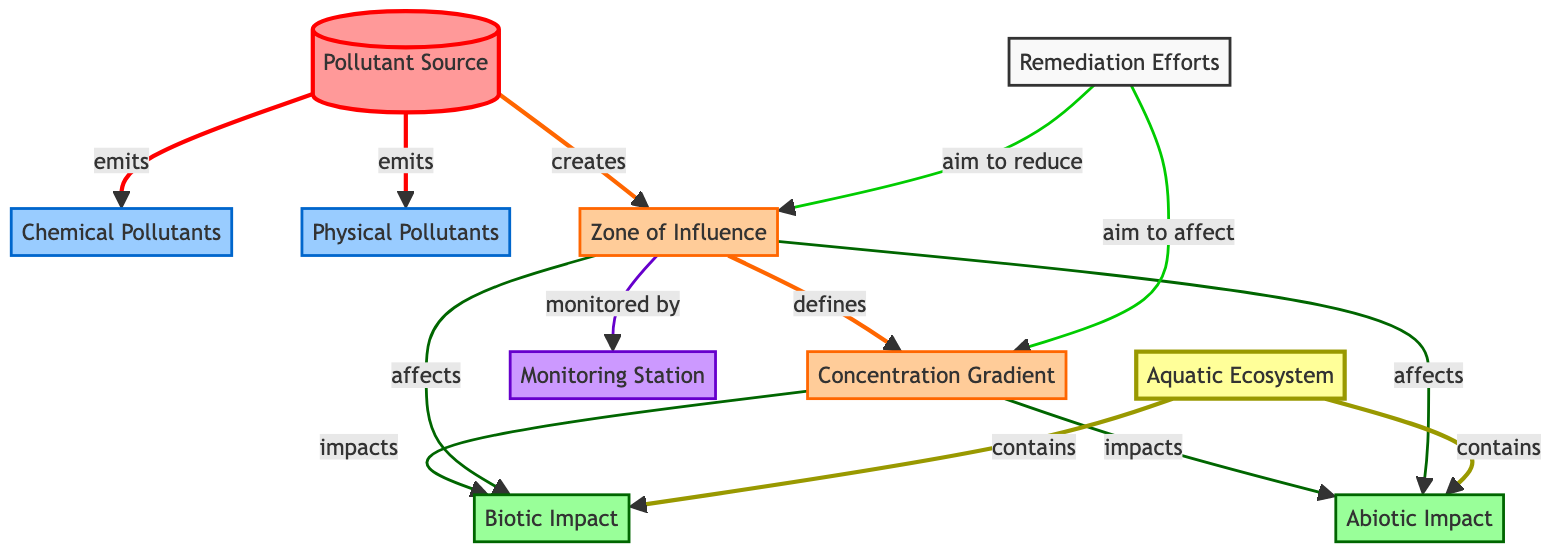What types of pollutants are emitted by the source? The diagram shows two types of pollutants that the source emits: Chemical Pollutants and Physical Pollutants. Both are linked directly to the Pollutant Source node.
Answer: Chemical Pollutants, Physical Pollutants What impacts are influenced by the Zone of Influence? The diagram indicates that the Zone of Influence affects both Biotic Impact and Abiotic Impact. This connection is shown through directed arrows leading from the Zone of Influence node to both impact nodes.
Answer: Biotic Impact, Abiotic Impact How many monitoring stations are mentioned in the diagram? The diagram includes one Monitoring Station, represented by the corresponding node. There are no additional monitoring stations depicted.
Answer: 1 What does the Concentration Gradient impact? According to the diagram, the Concentration Gradient impacts both Biotic Impact and Abiotic Impact. There are arrows leading from the Concentration Gradient to both of these impacts, indicating their relationship.
Answer: Biotic Impact, Abiotic Impact Which node aims to reduce the Zone of Influence? The diagram illustrates that Remediation Efforts aim to reduce the Zone of Influence. This is represented by a directed link from the Remediation Efforts node to the Zone of Influence node.
Answer: Remediation Efforts What defines the Concentration Gradient? The diagram specifies that the Zone of Influence defines the Concentration Gradient. This is indicated by the directed link from the Zone of Influence to the Concentration Gradient node.
Answer: Zone of Influence How does the Zone of Influence relate to the Aquatic Ecosystem? The Zone of Influence affects both Biotic and Abiotic impacts, which in turn are contained within the Aquatic Ecosystem. This relationship illustrates that the Zone of Influence plays a crucial role in determining the health of the ecosystem.
Answer: Affects health of the ecosystem Which class represents the pollutants in the diagram? The pollutants are represented by the "pollutant" class, which is color-coded in a specific shade (light blue) and outlined with defined stroke properties in the diagram.
Answer: pollutant 